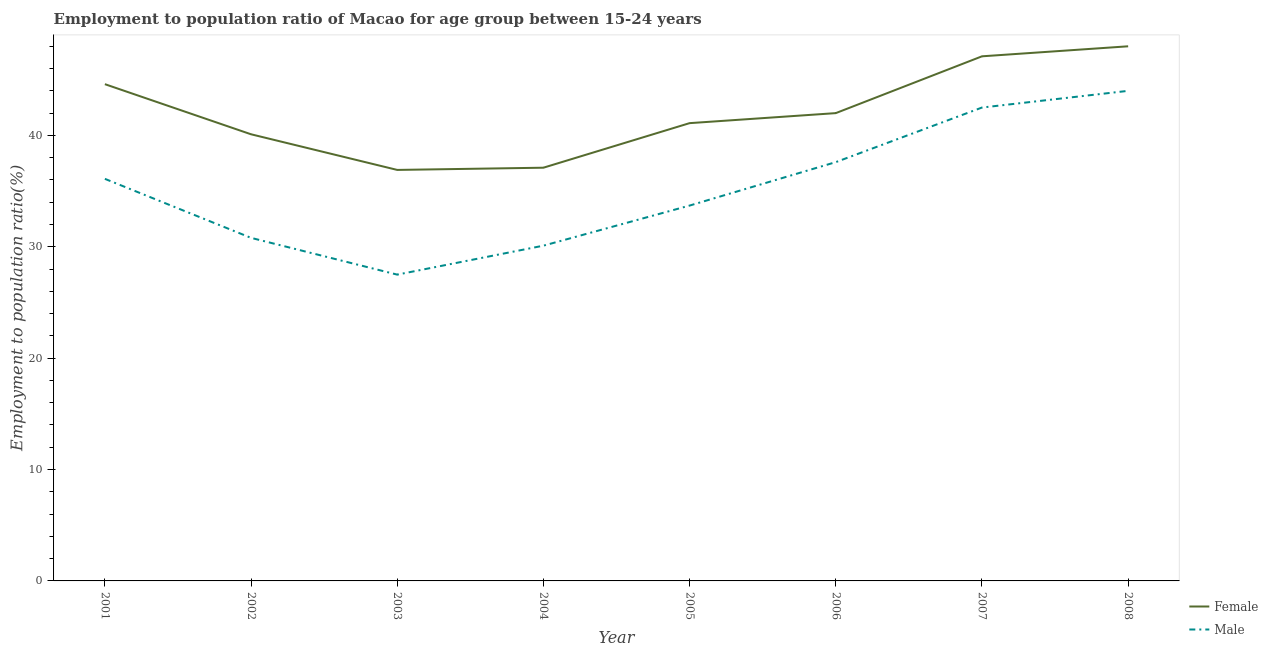Does the line corresponding to employment to population ratio(male) intersect with the line corresponding to employment to population ratio(female)?
Your answer should be compact. No. Is the number of lines equal to the number of legend labels?
Offer a very short reply. Yes. What is the employment to population ratio(male) in 2005?
Ensure brevity in your answer.  33.7. In which year was the employment to population ratio(female) maximum?
Give a very brief answer. 2008. In which year was the employment to population ratio(male) minimum?
Offer a terse response. 2003. What is the total employment to population ratio(male) in the graph?
Offer a very short reply. 282.3. What is the difference between the employment to population ratio(female) in 2006 and that in 2007?
Make the answer very short. -5.1. What is the difference between the employment to population ratio(male) in 2001 and the employment to population ratio(female) in 2008?
Your response must be concise. -11.9. What is the average employment to population ratio(female) per year?
Keep it short and to the point. 42.11. In the year 2004, what is the difference between the employment to population ratio(male) and employment to population ratio(female)?
Your answer should be compact. -7. In how many years, is the employment to population ratio(male) greater than 2 %?
Offer a very short reply. 8. What is the ratio of the employment to population ratio(male) in 2002 to that in 2006?
Provide a succinct answer. 0.82. Is the employment to population ratio(male) in 2003 less than that in 2005?
Provide a succinct answer. Yes. Is the difference between the employment to population ratio(male) in 2004 and 2006 greater than the difference between the employment to population ratio(female) in 2004 and 2006?
Offer a terse response. No. What is the difference between the highest and the second highest employment to population ratio(male)?
Give a very brief answer. 1.5. Does the employment to population ratio(male) monotonically increase over the years?
Your response must be concise. No. Is the employment to population ratio(female) strictly greater than the employment to population ratio(male) over the years?
Provide a succinct answer. Yes. How many lines are there?
Provide a short and direct response. 2. How many years are there in the graph?
Make the answer very short. 8. Are the values on the major ticks of Y-axis written in scientific E-notation?
Provide a succinct answer. No. Does the graph contain grids?
Make the answer very short. No. Where does the legend appear in the graph?
Give a very brief answer. Bottom right. What is the title of the graph?
Provide a succinct answer. Employment to population ratio of Macao for age group between 15-24 years. Does "International Tourists" appear as one of the legend labels in the graph?
Offer a terse response. No. What is the label or title of the X-axis?
Ensure brevity in your answer.  Year. What is the Employment to population ratio(%) of Female in 2001?
Make the answer very short. 44.6. What is the Employment to population ratio(%) of Male in 2001?
Ensure brevity in your answer.  36.1. What is the Employment to population ratio(%) of Female in 2002?
Keep it short and to the point. 40.1. What is the Employment to population ratio(%) in Male in 2002?
Offer a very short reply. 30.8. What is the Employment to population ratio(%) of Female in 2003?
Give a very brief answer. 36.9. What is the Employment to population ratio(%) of Female in 2004?
Give a very brief answer. 37.1. What is the Employment to population ratio(%) of Male in 2004?
Ensure brevity in your answer.  30.1. What is the Employment to population ratio(%) in Female in 2005?
Your answer should be compact. 41.1. What is the Employment to population ratio(%) in Male in 2005?
Provide a succinct answer. 33.7. What is the Employment to population ratio(%) of Female in 2006?
Make the answer very short. 42. What is the Employment to population ratio(%) of Male in 2006?
Offer a terse response. 37.6. What is the Employment to population ratio(%) in Female in 2007?
Keep it short and to the point. 47.1. What is the Employment to population ratio(%) of Male in 2007?
Keep it short and to the point. 42.5. What is the Employment to population ratio(%) in Male in 2008?
Offer a terse response. 44. Across all years, what is the maximum Employment to population ratio(%) of Female?
Offer a very short reply. 48. Across all years, what is the maximum Employment to population ratio(%) in Male?
Provide a short and direct response. 44. Across all years, what is the minimum Employment to population ratio(%) in Female?
Your answer should be very brief. 36.9. Across all years, what is the minimum Employment to population ratio(%) of Male?
Provide a succinct answer. 27.5. What is the total Employment to population ratio(%) of Female in the graph?
Your response must be concise. 336.9. What is the total Employment to population ratio(%) in Male in the graph?
Your answer should be very brief. 282.3. What is the difference between the Employment to population ratio(%) in Female in 2001 and that in 2003?
Keep it short and to the point. 7.7. What is the difference between the Employment to population ratio(%) in Female in 2001 and that in 2004?
Ensure brevity in your answer.  7.5. What is the difference between the Employment to population ratio(%) in Male in 2001 and that in 2004?
Keep it short and to the point. 6. What is the difference between the Employment to population ratio(%) in Female in 2001 and that in 2005?
Offer a terse response. 3.5. What is the difference between the Employment to population ratio(%) in Male in 2001 and that in 2005?
Ensure brevity in your answer.  2.4. What is the difference between the Employment to population ratio(%) of Female in 2001 and that in 2006?
Ensure brevity in your answer.  2.6. What is the difference between the Employment to population ratio(%) of Female in 2001 and that in 2007?
Offer a terse response. -2.5. What is the difference between the Employment to population ratio(%) in Female in 2001 and that in 2008?
Your response must be concise. -3.4. What is the difference between the Employment to population ratio(%) of Male in 2002 and that in 2003?
Provide a succinct answer. 3.3. What is the difference between the Employment to population ratio(%) of Male in 2002 and that in 2004?
Ensure brevity in your answer.  0.7. What is the difference between the Employment to population ratio(%) in Female in 2002 and that in 2005?
Give a very brief answer. -1. What is the difference between the Employment to population ratio(%) in Male in 2002 and that in 2005?
Give a very brief answer. -2.9. What is the difference between the Employment to population ratio(%) of Male in 2002 and that in 2006?
Offer a terse response. -6.8. What is the difference between the Employment to population ratio(%) in Male in 2002 and that in 2008?
Your answer should be very brief. -13.2. What is the difference between the Employment to population ratio(%) of Female in 2003 and that in 2004?
Offer a terse response. -0.2. What is the difference between the Employment to population ratio(%) of Male in 2003 and that in 2004?
Your answer should be compact. -2.6. What is the difference between the Employment to population ratio(%) in Female in 2003 and that in 2007?
Offer a terse response. -10.2. What is the difference between the Employment to population ratio(%) in Female in 2003 and that in 2008?
Provide a short and direct response. -11.1. What is the difference between the Employment to population ratio(%) of Male in 2003 and that in 2008?
Offer a terse response. -16.5. What is the difference between the Employment to population ratio(%) in Female in 2004 and that in 2005?
Keep it short and to the point. -4. What is the difference between the Employment to population ratio(%) in Male in 2004 and that in 2005?
Your answer should be compact. -3.6. What is the difference between the Employment to population ratio(%) of Female in 2004 and that in 2006?
Give a very brief answer. -4.9. What is the difference between the Employment to population ratio(%) in Female in 2004 and that in 2007?
Your answer should be very brief. -10. What is the difference between the Employment to population ratio(%) in Female in 2005 and that in 2007?
Your answer should be very brief. -6. What is the difference between the Employment to population ratio(%) of Male in 2005 and that in 2007?
Give a very brief answer. -8.8. What is the difference between the Employment to population ratio(%) of Male in 2005 and that in 2008?
Provide a succinct answer. -10.3. What is the difference between the Employment to population ratio(%) of Female in 2006 and that in 2007?
Provide a succinct answer. -5.1. What is the difference between the Employment to population ratio(%) of Male in 2006 and that in 2007?
Your answer should be very brief. -4.9. What is the difference between the Employment to population ratio(%) of Female in 2006 and that in 2008?
Give a very brief answer. -6. What is the difference between the Employment to population ratio(%) in Male in 2006 and that in 2008?
Offer a very short reply. -6.4. What is the difference between the Employment to population ratio(%) in Female in 2007 and that in 2008?
Provide a succinct answer. -0.9. What is the difference between the Employment to population ratio(%) of Female in 2001 and the Employment to population ratio(%) of Male in 2006?
Offer a terse response. 7. What is the difference between the Employment to population ratio(%) in Female in 2001 and the Employment to population ratio(%) in Male in 2007?
Give a very brief answer. 2.1. What is the difference between the Employment to population ratio(%) of Female in 2002 and the Employment to population ratio(%) of Male in 2003?
Offer a terse response. 12.6. What is the difference between the Employment to population ratio(%) of Female in 2002 and the Employment to population ratio(%) of Male in 2004?
Ensure brevity in your answer.  10. What is the difference between the Employment to population ratio(%) in Female in 2002 and the Employment to population ratio(%) in Male in 2006?
Your answer should be very brief. 2.5. What is the difference between the Employment to population ratio(%) in Female in 2002 and the Employment to population ratio(%) in Male in 2007?
Keep it short and to the point. -2.4. What is the difference between the Employment to population ratio(%) of Female in 2002 and the Employment to population ratio(%) of Male in 2008?
Make the answer very short. -3.9. What is the difference between the Employment to population ratio(%) of Female in 2003 and the Employment to population ratio(%) of Male in 2004?
Keep it short and to the point. 6.8. What is the difference between the Employment to population ratio(%) in Female in 2004 and the Employment to population ratio(%) in Male in 2006?
Provide a succinct answer. -0.5. What is the difference between the Employment to population ratio(%) of Female in 2004 and the Employment to population ratio(%) of Male in 2007?
Make the answer very short. -5.4. What is the difference between the Employment to population ratio(%) of Female in 2005 and the Employment to population ratio(%) of Male in 2007?
Keep it short and to the point. -1.4. What is the difference between the Employment to population ratio(%) in Female in 2005 and the Employment to population ratio(%) in Male in 2008?
Your response must be concise. -2.9. What is the difference between the Employment to population ratio(%) of Female in 2006 and the Employment to population ratio(%) of Male in 2007?
Your answer should be very brief. -0.5. What is the difference between the Employment to population ratio(%) of Female in 2006 and the Employment to population ratio(%) of Male in 2008?
Provide a succinct answer. -2. What is the difference between the Employment to population ratio(%) of Female in 2007 and the Employment to population ratio(%) of Male in 2008?
Your answer should be compact. 3.1. What is the average Employment to population ratio(%) of Female per year?
Ensure brevity in your answer.  42.11. What is the average Employment to population ratio(%) of Male per year?
Give a very brief answer. 35.29. In the year 2001, what is the difference between the Employment to population ratio(%) in Female and Employment to population ratio(%) in Male?
Provide a short and direct response. 8.5. In the year 2003, what is the difference between the Employment to population ratio(%) in Female and Employment to population ratio(%) in Male?
Keep it short and to the point. 9.4. In the year 2005, what is the difference between the Employment to population ratio(%) of Female and Employment to population ratio(%) of Male?
Offer a very short reply. 7.4. In the year 2006, what is the difference between the Employment to population ratio(%) of Female and Employment to population ratio(%) of Male?
Give a very brief answer. 4.4. In the year 2007, what is the difference between the Employment to population ratio(%) of Female and Employment to population ratio(%) of Male?
Your answer should be very brief. 4.6. What is the ratio of the Employment to population ratio(%) of Female in 2001 to that in 2002?
Give a very brief answer. 1.11. What is the ratio of the Employment to population ratio(%) of Male in 2001 to that in 2002?
Your answer should be very brief. 1.17. What is the ratio of the Employment to population ratio(%) in Female in 2001 to that in 2003?
Ensure brevity in your answer.  1.21. What is the ratio of the Employment to population ratio(%) in Male in 2001 to that in 2003?
Give a very brief answer. 1.31. What is the ratio of the Employment to population ratio(%) of Female in 2001 to that in 2004?
Your response must be concise. 1.2. What is the ratio of the Employment to population ratio(%) in Male in 2001 to that in 2004?
Give a very brief answer. 1.2. What is the ratio of the Employment to population ratio(%) in Female in 2001 to that in 2005?
Provide a succinct answer. 1.09. What is the ratio of the Employment to population ratio(%) of Male in 2001 to that in 2005?
Offer a very short reply. 1.07. What is the ratio of the Employment to population ratio(%) of Female in 2001 to that in 2006?
Make the answer very short. 1.06. What is the ratio of the Employment to population ratio(%) in Male in 2001 to that in 2006?
Ensure brevity in your answer.  0.96. What is the ratio of the Employment to population ratio(%) of Female in 2001 to that in 2007?
Keep it short and to the point. 0.95. What is the ratio of the Employment to population ratio(%) of Male in 2001 to that in 2007?
Provide a succinct answer. 0.85. What is the ratio of the Employment to population ratio(%) in Female in 2001 to that in 2008?
Provide a short and direct response. 0.93. What is the ratio of the Employment to population ratio(%) in Male in 2001 to that in 2008?
Make the answer very short. 0.82. What is the ratio of the Employment to population ratio(%) in Female in 2002 to that in 2003?
Make the answer very short. 1.09. What is the ratio of the Employment to population ratio(%) of Male in 2002 to that in 2003?
Your answer should be compact. 1.12. What is the ratio of the Employment to population ratio(%) of Female in 2002 to that in 2004?
Keep it short and to the point. 1.08. What is the ratio of the Employment to population ratio(%) of Male in 2002 to that in 2004?
Ensure brevity in your answer.  1.02. What is the ratio of the Employment to population ratio(%) of Female in 2002 to that in 2005?
Your response must be concise. 0.98. What is the ratio of the Employment to population ratio(%) in Male in 2002 to that in 2005?
Offer a terse response. 0.91. What is the ratio of the Employment to population ratio(%) in Female in 2002 to that in 2006?
Make the answer very short. 0.95. What is the ratio of the Employment to population ratio(%) of Male in 2002 to that in 2006?
Your answer should be very brief. 0.82. What is the ratio of the Employment to population ratio(%) of Female in 2002 to that in 2007?
Make the answer very short. 0.85. What is the ratio of the Employment to population ratio(%) of Male in 2002 to that in 2007?
Provide a succinct answer. 0.72. What is the ratio of the Employment to population ratio(%) of Female in 2002 to that in 2008?
Your answer should be compact. 0.84. What is the ratio of the Employment to population ratio(%) of Male in 2002 to that in 2008?
Offer a terse response. 0.7. What is the ratio of the Employment to population ratio(%) in Female in 2003 to that in 2004?
Ensure brevity in your answer.  0.99. What is the ratio of the Employment to population ratio(%) of Male in 2003 to that in 2004?
Provide a short and direct response. 0.91. What is the ratio of the Employment to population ratio(%) in Female in 2003 to that in 2005?
Provide a short and direct response. 0.9. What is the ratio of the Employment to population ratio(%) of Male in 2003 to that in 2005?
Keep it short and to the point. 0.82. What is the ratio of the Employment to population ratio(%) in Female in 2003 to that in 2006?
Provide a short and direct response. 0.88. What is the ratio of the Employment to population ratio(%) of Male in 2003 to that in 2006?
Give a very brief answer. 0.73. What is the ratio of the Employment to population ratio(%) of Female in 2003 to that in 2007?
Provide a short and direct response. 0.78. What is the ratio of the Employment to population ratio(%) of Male in 2003 to that in 2007?
Provide a succinct answer. 0.65. What is the ratio of the Employment to population ratio(%) of Female in 2003 to that in 2008?
Give a very brief answer. 0.77. What is the ratio of the Employment to population ratio(%) in Female in 2004 to that in 2005?
Make the answer very short. 0.9. What is the ratio of the Employment to population ratio(%) of Male in 2004 to that in 2005?
Your answer should be compact. 0.89. What is the ratio of the Employment to population ratio(%) in Female in 2004 to that in 2006?
Make the answer very short. 0.88. What is the ratio of the Employment to population ratio(%) in Male in 2004 to that in 2006?
Your answer should be very brief. 0.8. What is the ratio of the Employment to population ratio(%) in Female in 2004 to that in 2007?
Provide a short and direct response. 0.79. What is the ratio of the Employment to population ratio(%) in Male in 2004 to that in 2007?
Your answer should be very brief. 0.71. What is the ratio of the Employment to population ratio(%) in Female in 2004 to that in 2008?
Ensure brevity in your answer.  0.77. What is the ratio of the Employment to population ratio(%) of Male in 2004 to that in 2008?
Make the answer very short. 0.68. What is the ratio of the Employment to population ratio(%) in Female in 2005 to that in 2006?
Give a very brief answer. 0.98. What is the ratio of the Employment to population ratio(%) in Male in 2005 to that in 2006?
Your answer should be compact. 0.9. What is the ratio of the Employment to population ratio(%) of Female in 2005 to that in 2007?
Offer a very short reply. 0.87. What is the ratio of the Employment to population ratio(%) of Male in 2005 to that in 2007?
Your answer should be very brief. 0.79. What is the ratio of the Employment to population ratio(%) of Female in 2005 to that in 2008?
Your response must be concise. 0.86. What is the ratio of the Employment to population ratio(%) in Male in 2005 to that in 2008?
Your answer should be very brief. 0.77. What is the ratio of the Employment to population ratio(%) of Female in 2006 to that in 2007?
Offer a very short reply. 0.89. What is the ratio of the Employment to population ratio(%) of Male in 2006 to that in 2007?
Provide a short and direct response. 0.88. What is the ratio of the Employment to population ratio(%) of Female in 2006 to that in 2008?
Your answer should be compact. 0.88. What is the ratio of the Employment to population ratio(%) of Male in 2006 to that in 2008?
Your response must be concise. 0.85. What is the ratio of the Employment to population ratio(%) in Female in 2007 to that in 2008?
Keep it short and to the point. 0.98. What is the ratio of the Employment to population ratio(%) in Male in 2007 to that in 2008?
Provide a succinct answer. 0.97. What is the difference between the highest and the second highest Employment to population ratio(%) in Female?
Your response must be concise. 0.9. What is the difference between the highest and the lowest Employment to population ratio(%) in Female?
Keep it short and to the point. 11.1. 